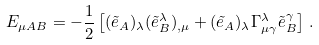Convert formula to latex. <formula><loc_0><loc_0><loc_500><loc_500>E _ { \mu A B } = - \frac { 1 } { 2 } \left [ ( \tilde { e } _ { A } ) _ { \lambda } ( \tilde { e } ^ { \lambda } _ { B } ) _ { , \mu } + ( \tilde { e } _ { A } ) _ { \lambda } \Gamma ^ { \lambda } _ { \mu \gamma } \tilde { e } ^ { \gamma } _ { B } \right ] \, .</formula> 